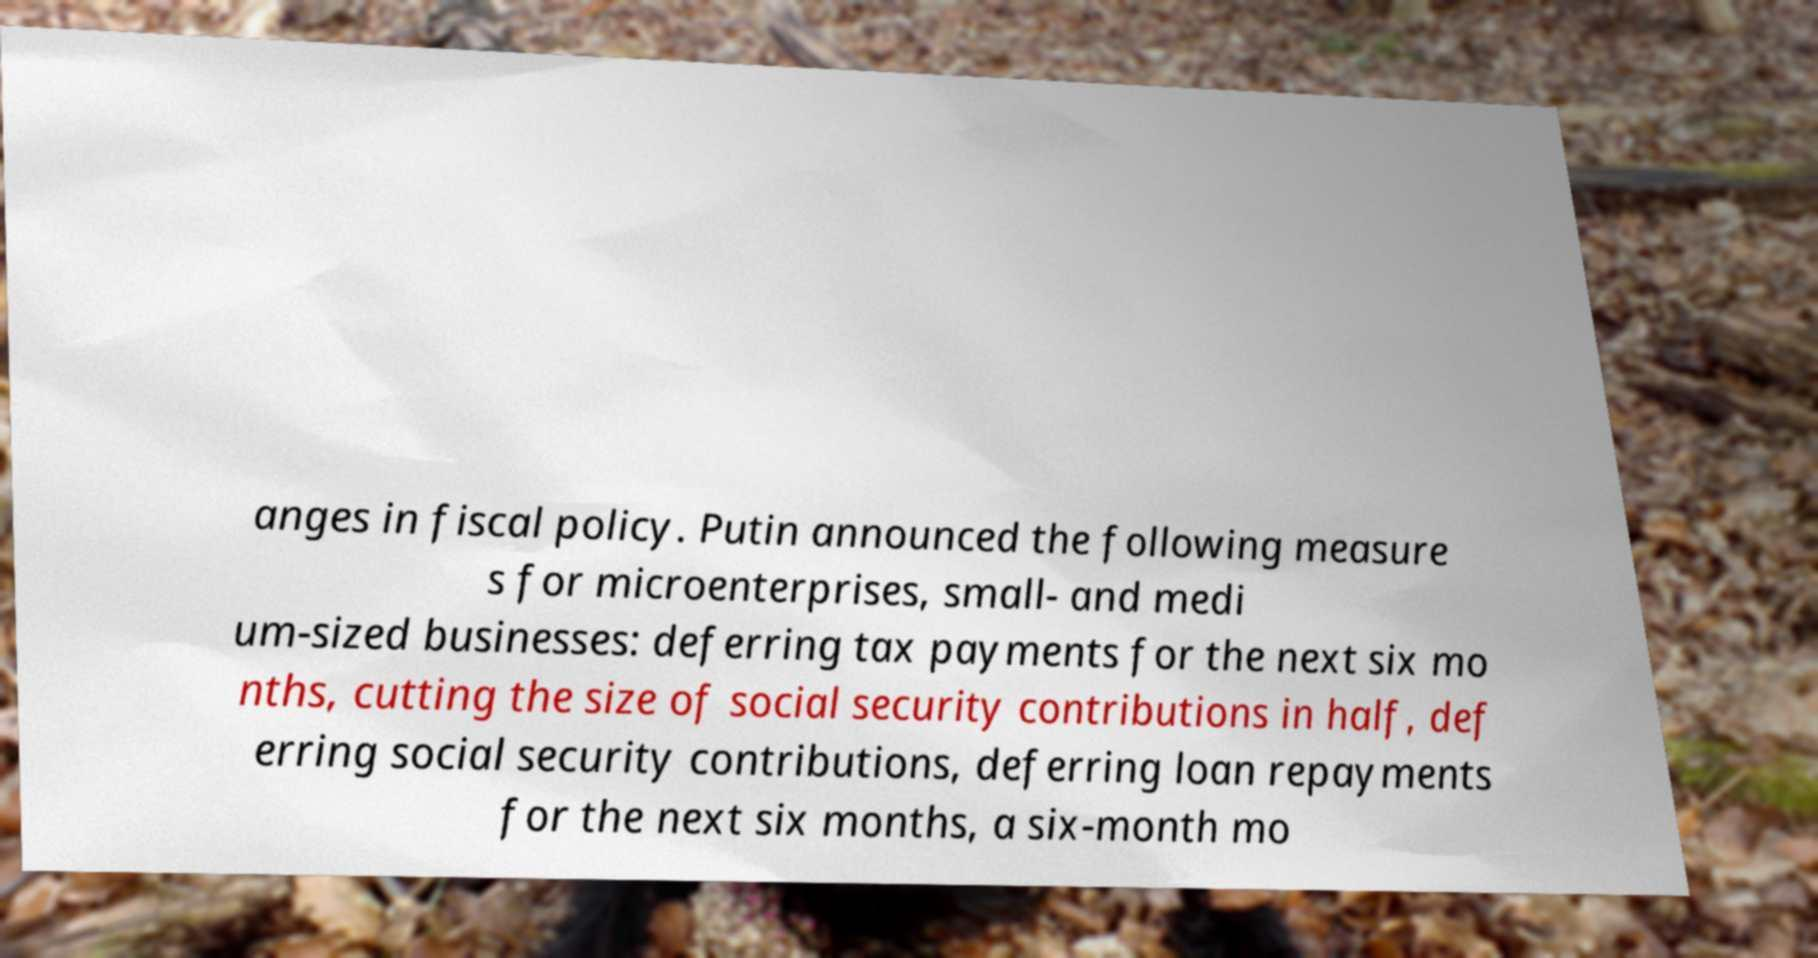Could you extract and type out the text from this image? anges in fiscal policy. Putin announced the following measure s for microenterprises, small- and medi um-sized businesses: deferring tax payments for the next six mo nths, cutting the size of social security contributions in half, def erring social security contributions, deferring loan repayments for the next six months, a six-month mo 